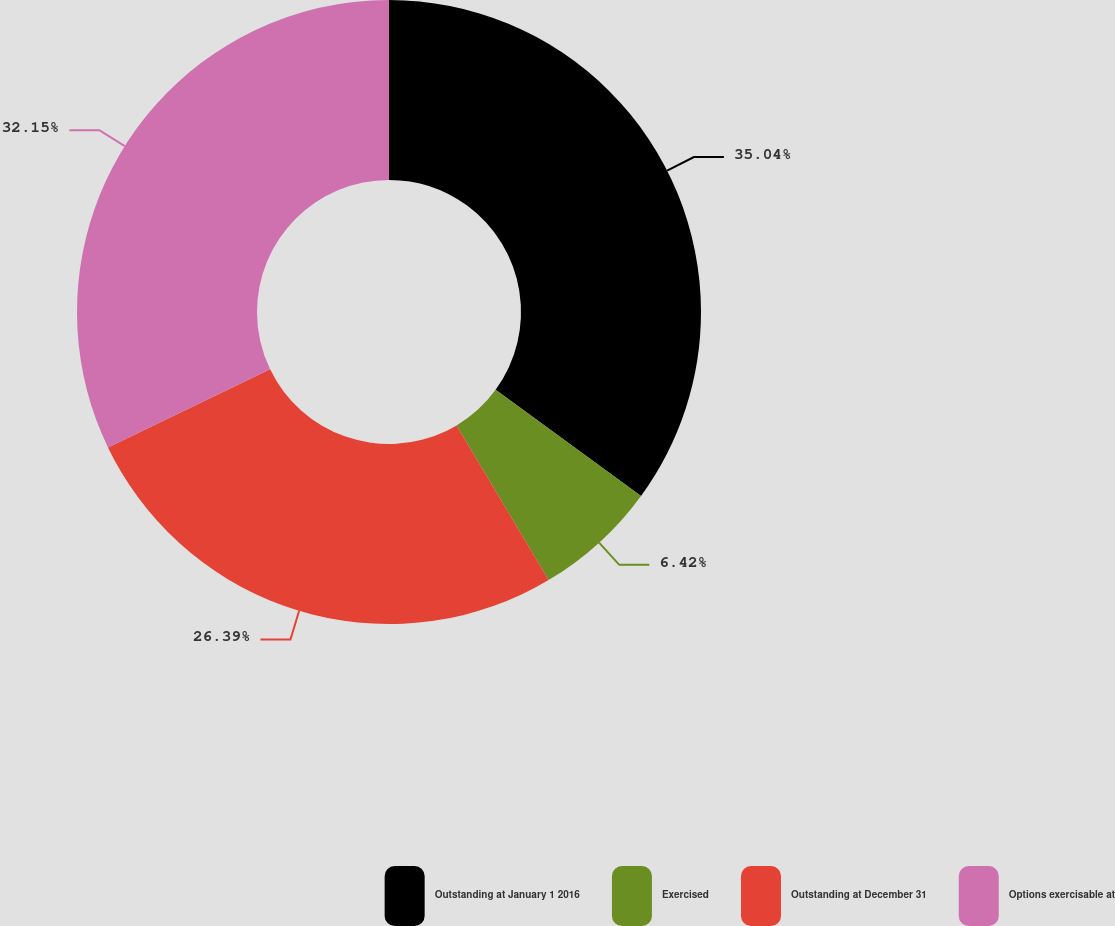Convert chart to OTSL. <chart><loc_0><loc_0><loc_500><loc_500><pie_chart><fcel>Outstanding at January 1 2016<fcel>Exercised<fcel>Outstanding at December 31<fcel>Options exercisable at<nl><fcel>35.03%<fcel>6.42%<fcel>26.39%<fcel>32.15%<nl></chart> 